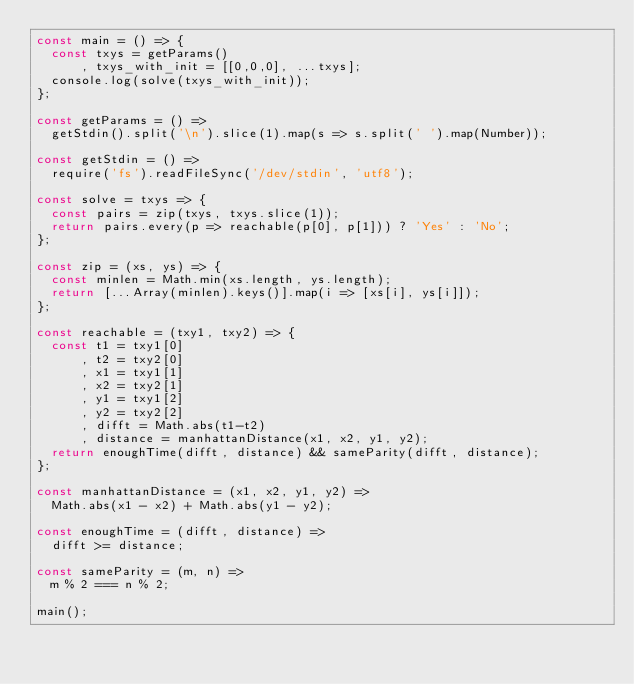Convert code to text. <code><loc_0><loc_0><loc_500><loc_500><_JavaScript_>const main = () => {
  const txys = getParams()
      , txys_with_init = [[0,0,0], ...txys];
  console.log(solve(txys_with_init));
};

const getParams = () =>
  getStdin().split('\n').slice(1).map(s => s.split(' ').map(Number));

const getStdin = () =>
  require('fs').readFileSync('/dev/stdin', 'utf8');

const solve = txys => {
  const pairs = zip(txys, txys.slice(1));
  return pairs.every(p => reachable(p[0], p[1])) ? 'Yes' : 'No';
};

const zip = (xs, ys) => {
  const minlen = Math.min(xs.length, ys.length);
  return [...Array(minlen).keys()].map(i => [xs[i], ys[i]]);
};

const reachable = (txy1, txy2) => {
  const t1 = txy1[0]
      , t2 = txy2[0]
      , x1 = txy1[1]
      , x2 = txy2[1]
      , y1 = txy1[2]
      , y2 = txy2[2]
      , difft = Math.abs(t1-t2)
      , distance = manhattanDistance(x1, x2, y1, y2);
  return enoughTime(difft, distance) && sameParity(difft, distance);
};

const manhattanDistance = (x1, x2, y1, y2) =>
  Math.abs(x1 - x2) + Math.abs(y1 - y2);

const enoughTime = (difft, distance) =>
  difft >= distance;

const sameParity = (m, n) =>
  m % 2 === n % 2;

main();
</code> 